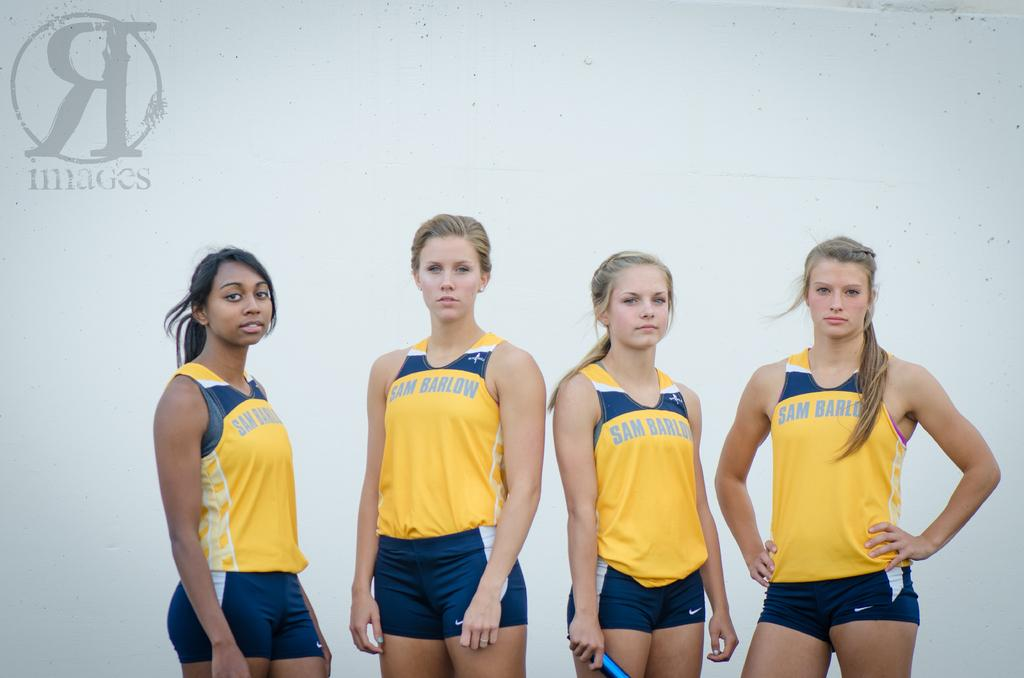<image>
Summarize the visual content of the image. 4 female athletes are wearing yellow and blue Sam Barlow tank tops. 